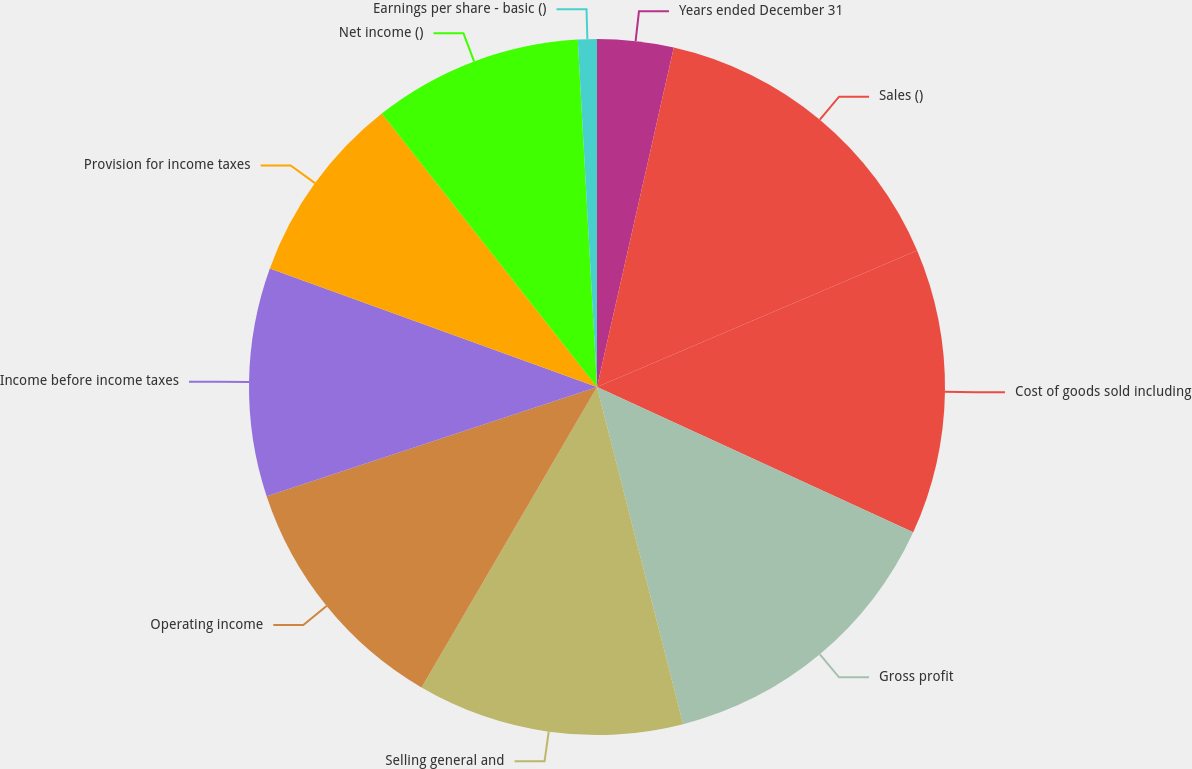Convert chart to OTSL. <chart><loc_0><loc_0><loc_500><loc_500><pie_chart><fcel>Years ended December 31<fcel>Sales ()<fcel>Cost of goods sold including<fcel>Gross profit<fcel>Selling general and<fcel>Operating income<fcel>Income before income taxes<fcel>Provision for income taxes<fcel>Net income ()<fcel>Earnings per share - basic ()<nl><fcel>3.54%<fcel>15.04%<fcel>13.27%<fcel>14.16%<fcel>12.39%<fcel>11.5%<fcel>10.62%<fcel>8.85%<fcel>9.73%<fcel>0.88%<nl></chart> 